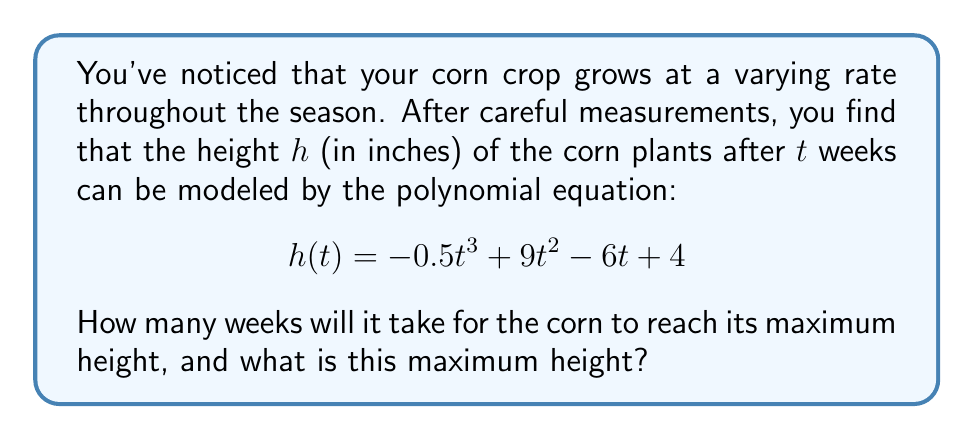Teach me how to tackle this problem. To find the maximum height and when it occurs, we need to follow these steps:

1) The maximum height will occur when the rate of change (first derivative) of the height function is zero. Let's find the first derivative:

   $$h'(t) = -1.5t^2 + 18t - 6$$

2) Set this equal to zero and solve for t:

   $$-1.5t^2 + 18t - 6 = 0$$

3) This is a quadratic equation. We can solve it using the quadratic formula:
   
   $$t = \frac{-b \pm \sqrt{b^2 - 4ac}}{2a}$$

   where $a = -1.5$, $b = 18$, and $c = -6$

4) Plugging in these values:

   $$t = \frac{-18 \pm \sqrt{18^2 - 4(-1.5)(-6)}}{2(-1.5)} = \frac{-18 \pm \sqrt{324 - 36}}{-3} = \frac{-18 \pm \sqrt{288}}{-3}$$

5) Simplifying:

   $$t = \frac{-18 \pm 12\sqrt{2}}{-3} = 6 \pm 2\sqrt{2}$$

6) This gives us two solutions: $6 + 2\sqrt{2}$ and $6 - 2\sqrt{2}$. Since we're looking for the maximum height, we want the later time, which is $6 + 2\sqrt{2}$ weeks.

7) To find the maximum height, we plug this value of t back into our original equation:

   $$h(6 + 2\sqrt{2}) = -0.5(6 + 2\sqrt{2})^3 + 9(6 + 2\sqrt{2})^2 - 6(6 + 2\sqrt{2}) + 4$$

8) Simplifying this (which involves some complex algebra) gives us the maximum height.
Answer: $6 + 2\sqrt{2}$ weeks; $100 + 16\sqrt{2}$ inches 